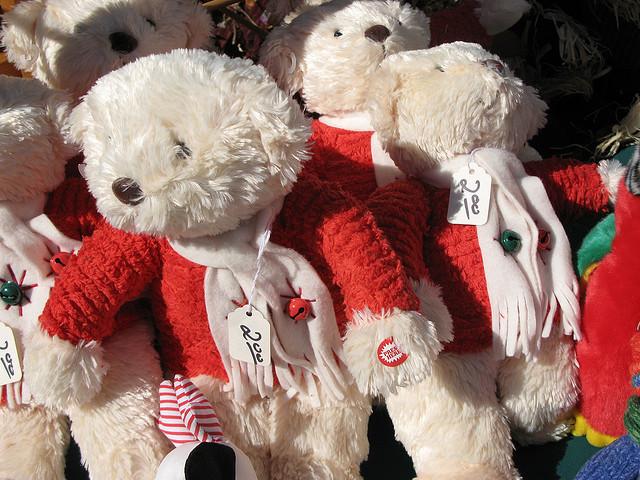How many bear noses are in the picture?
Concise answer only. 4. What color is the bears  sweater?
Short answer required. Red. How much does each bear cost?
Keep it brief. 2.00. 